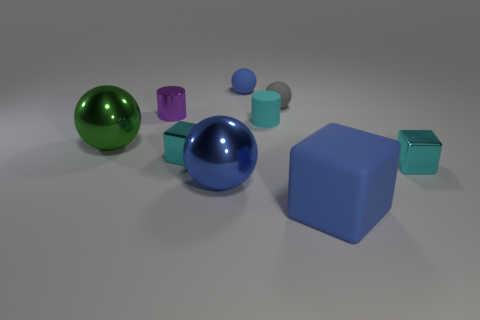Can you describe the shapes of the objects and discuss any patterns you may notice? Certainly. The variety of geometric shapes in the image includes spheres, cylinders, and cubes. There are two spherical objects, one blue and one green, which exhibit perfect symmetry from all angles. The cube, featured prominently in the foreground, boasts equal sides and sharp edges, providing a distinct contrast to the roundness of the spheres. The pair of cyan objects consists of a cylinder and a smaller right circular cylinder, both showcasing axial symmetry. A common pattern is the repetition of shapes, like the two spherical objects and two cylindrical shapes but in different sizes, creating a harmonious yet diverse visual collection. 